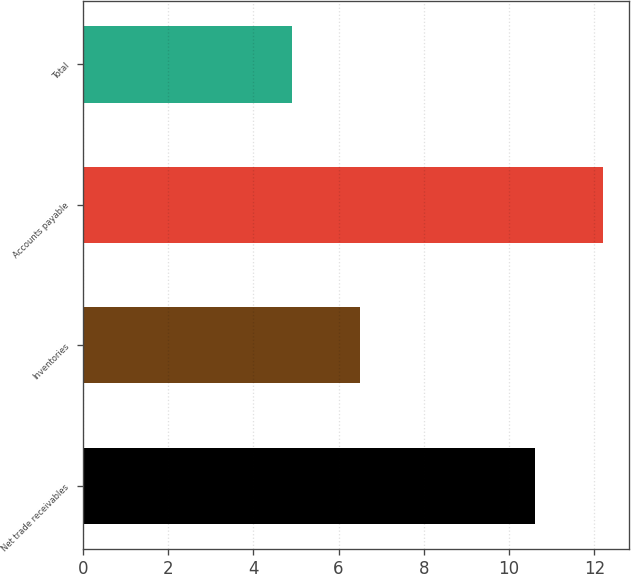Convert chart. <chart><loc_0><loc_0><loc_500><loc_500><bar_chart><fcel>Net trade receivables<fcel>Inventories<fcel>Accounts payable<fcel>Total<nl><fcel>10.6<fcel>6.5<fcel>12.2<fcel>4.9<nl></chart> 